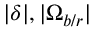Convert formula to latex. <formula><loc_0><loc_0><loc_500><loc_500>| \delta | , | \Omega _ { b / r } |</formula> 